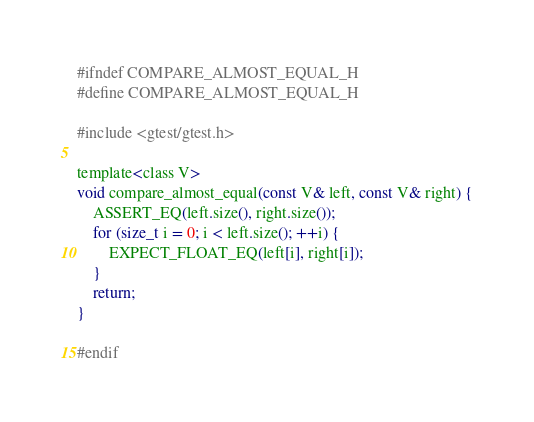Convert code to text. <code><loc_0><loc_0><loc_500><loc_500><_C_>#ifndef COMPARE_ALMOST_EQUAL_H
#define COMPARE_ALMOST_EQUAL_H

#include <gtest/gtest.h>

template<class V>
void compare_almost_equal(const V& left, const V& right) {
    ASSERT_EQ(left.size(), right.size());
    for (size_t i = 0; i < left.size(); ++i) {
        EXPECT_FLOAT_EQ(left[i], right[i]);
    }
    return;
}

#endif
</code> 